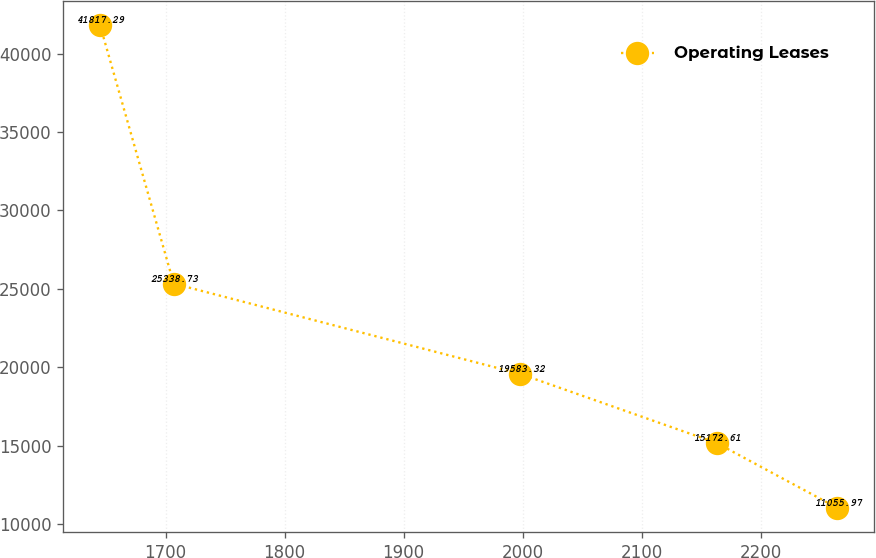Convert chart to OTSL. <chart><loc_0><loc_0><loc_500><loc_500><line_chart><ecel><fcel>Operating Leases<nl><fcel>1644.95<fcel>41817.3<nl><fcel>1706.87<fcel>25338.7<nl><fcel>1998.12<fcel>19583.3<nl><fcel>2163.22<fcel>15172.6<nl><fcel>2264.18<fcel>11056<nl></chart> 